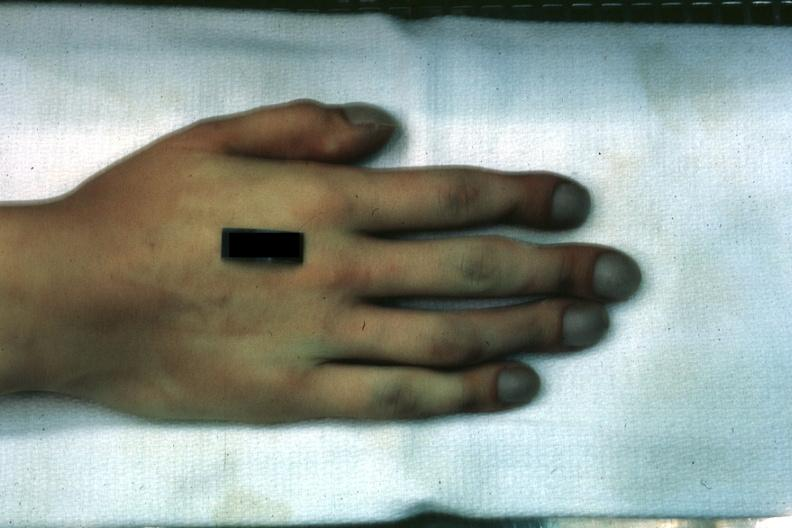s nodular tumor present?
Answer the question using a single word or phrase. No 